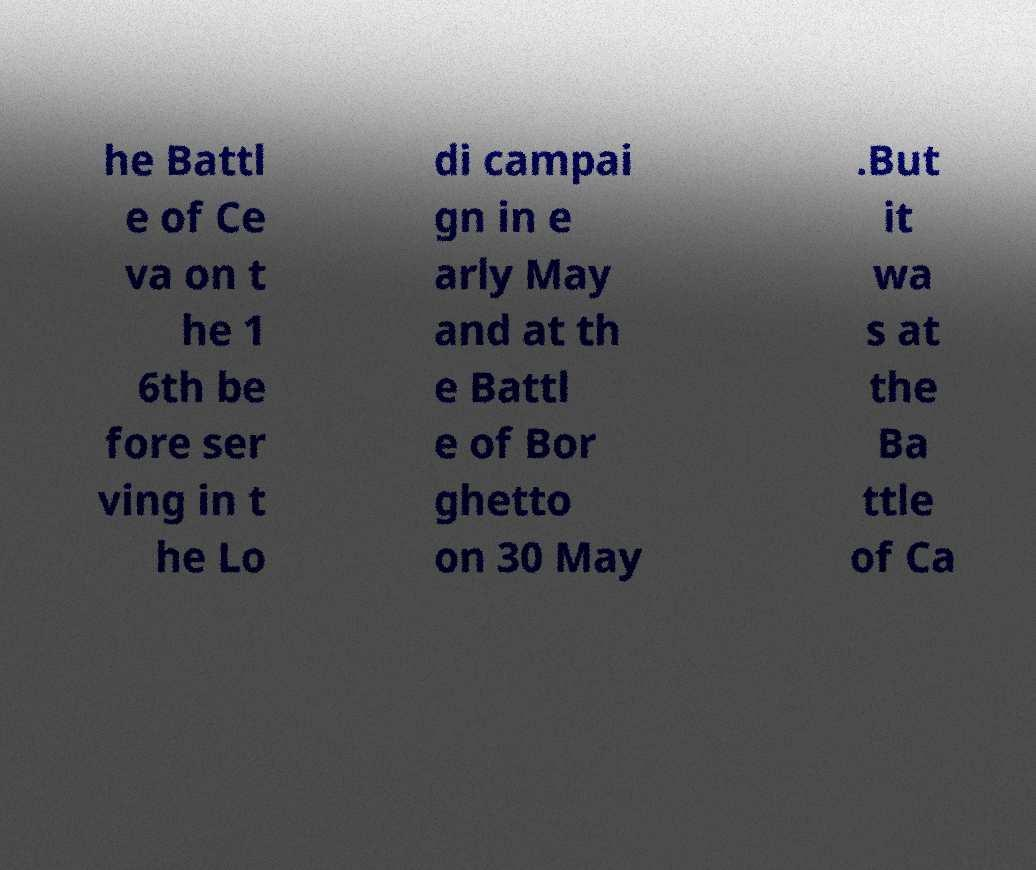Please identify and transcribe the text found in this image. he Battl e of Ce va on t he 1 6th be fore ser ving in t he Lo di campai gn in e arly May and at th e Battl e of Bor ghetto on 30 May .But it wa s at the Ba ttle of Ca 